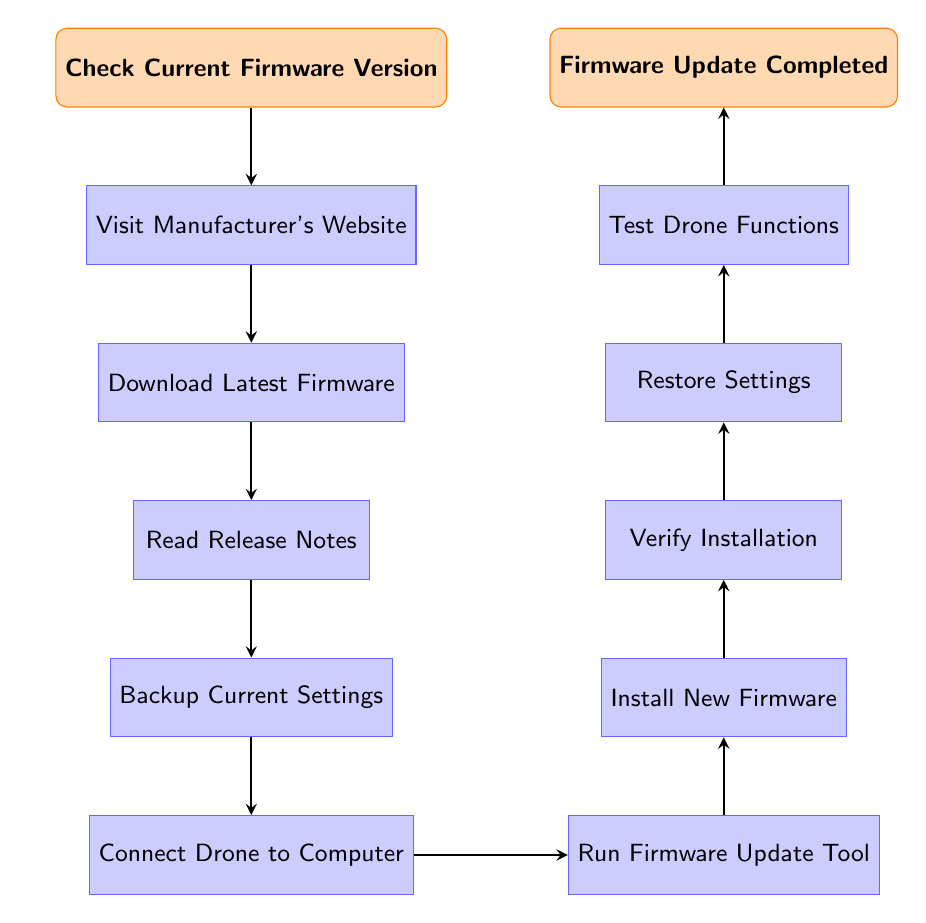What is the starting point of the flow chart? The flow chart begins with the node labeled "Check Current Firmware Version". This is the first action to be taken in the process.
Answer: Check Current Firmware Version How many process nodes are present in the flow chart? The flow chart contains ten process nodes in total from start to finish. This includes all steps involved in updating the firmware.
Answer: Ten Which step follows "Connect Drone to Computer"? The step that follows "Connect Drone to Computer" is "Run Firmware Update Tool". This is the immediate next action in the sequence.
Answer: Run Firmware Update Tool What is the final step in the flow chart? The last step in the flow chart is "Firmware Update Completed". This indicates that the firmware update process has concluded successfully.
Answer: Firmware Update Completed What action should be performed after "Install New Firmware"? After "Install New Firmware", the next action is "Verify Installation". This is vital to ensure the new firmware is functioning properly before proceeding.
Answer: Verify Installation What must be done before "Install New Firmware"? Before "Install New Firmware", you need to "Run Firmware Update Tool". This step is essential to initiate the firmware installation process.
Answer: Run Firmware Update Tool Explain the path from "Backup Current Settings" to the completion of the update. From "Backup Current Settings", the next step is to "Connect Drone to Computer," followed by "Run Firmware Update Tool," then "Install New Firmware," which is followed by "Verify Installation," and finally leads to "Restore Settings" and "Test Drone Functions," completing with "Firmware Update Completed". This sequence ensures all necessary actions are performed after backing up settings.
Answer: Connect Drone to Computer, Run Firmware Update Tool, Install New Firmware, Verify Installation, Restore Settings, Test Drone Functions, Firmware Update Completed Identify the primary purpose of "Read Release Notes" in the process. The purpose of "Read Release Notes" is to inform the user about the new features and fixes provided in the latest firmware version to enhance understanding before installation.
Answer: Understanding new features and fixes What action immediately precedes "Test Drone Functions"? The action that immediately precedes "Test Drone Functions" is "Restore Settings". This step is critical as it ensures that the drone is set to its previous configuration before testing.
Answer: Restore Settings 